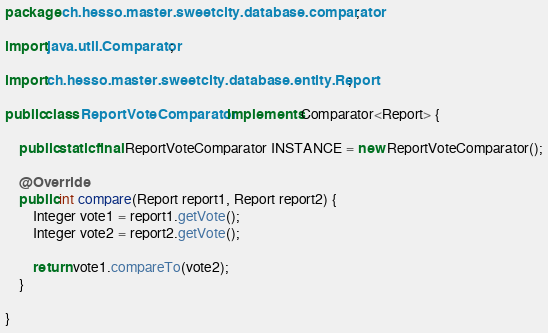Convert code to text. <code><loc_0><loc_0><loc_500><loc_500><_Java_>package ch.hesso.master.sweetcity.database.comparator;

import java.util.Comparator;

import ch.hesso.master.sweetcity.database.entity.Report;

public class ReportVoteComparator implements Comparator<Report> {
	
	public static final ReportVoteComparator INSTANCE = new ReportVoteComparator();
	
	@Override
	public int compare(Report report1, Report report2) {
		Integer vote1 = report1.getVote();
		Integer vote2 = report2.getVote();

		return vote1.compareTo(vote2);
	}

}
</code> 